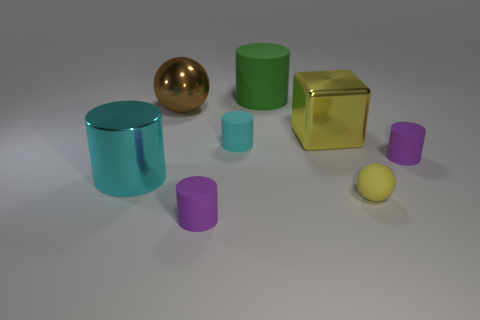Subtract all purple cylinders. How many cylinders are left? 3 Subtract all metal cylinders. How many cylinders are left? 4 Add 1 spheres. How many objects exist? 9 Subtract all blue cylinders. Subtract all yellow balls. How many cylinders are left? 5 Subtract all cubes. How many objects are left? 7 Add 8 blue objects. How many blue objects exist? 8 Subtract 0 red cubes. How many objects are left? 8 Subtract all metallic balls. Subtract all big matte cylinders. How many objects are left? 6 Add 6 big yellow shiny things. How many big yellow shiny things are left? 7 